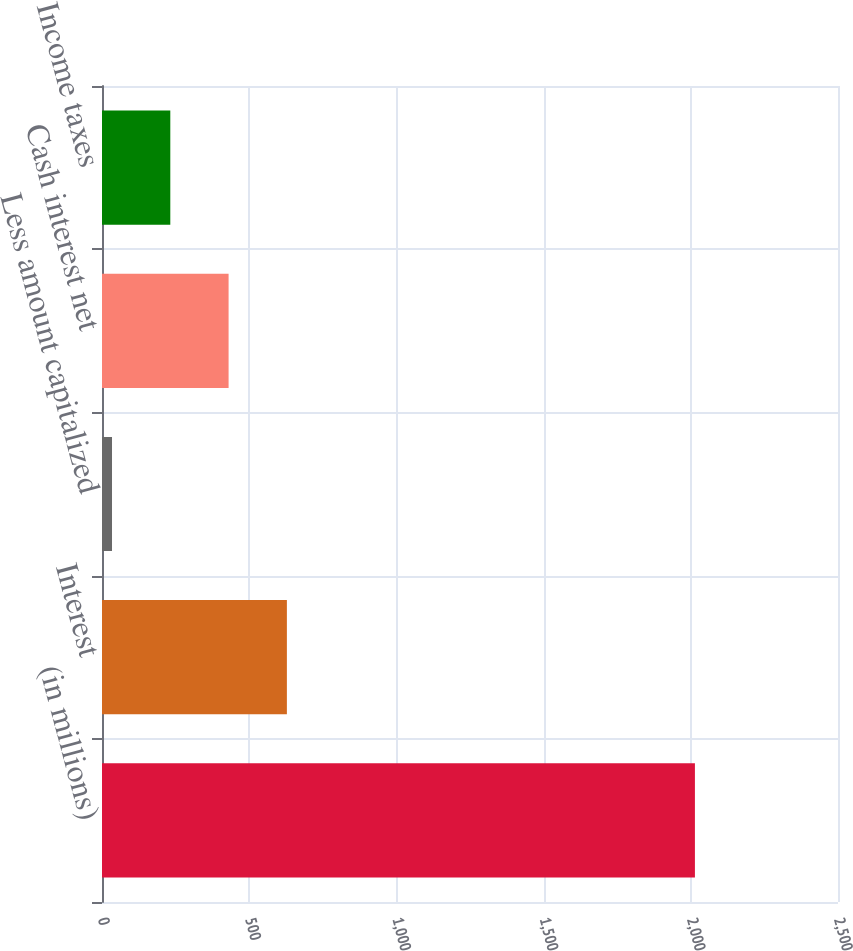<chart> <loc_0><loc_0><loc_500><loc_500><bar_chart><fcel>(in millions)<fcel>Interest<fcel>Less amount capitalized<fcel>Cash interest net<fcel>Income taxes<nl><fcel>2014<fcel>628<fcel>34<fcel>430<fcel>232<nl></chart> 